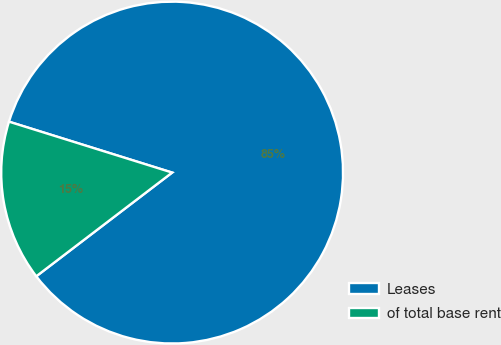Convert chart. <chart><loc_0><loc_0><loc_500><loc_500><pie_chart><fcel>Leases<fcel>of total base rent<nl><fcel>84.81%<fcel>15.19%<nl></chart> 